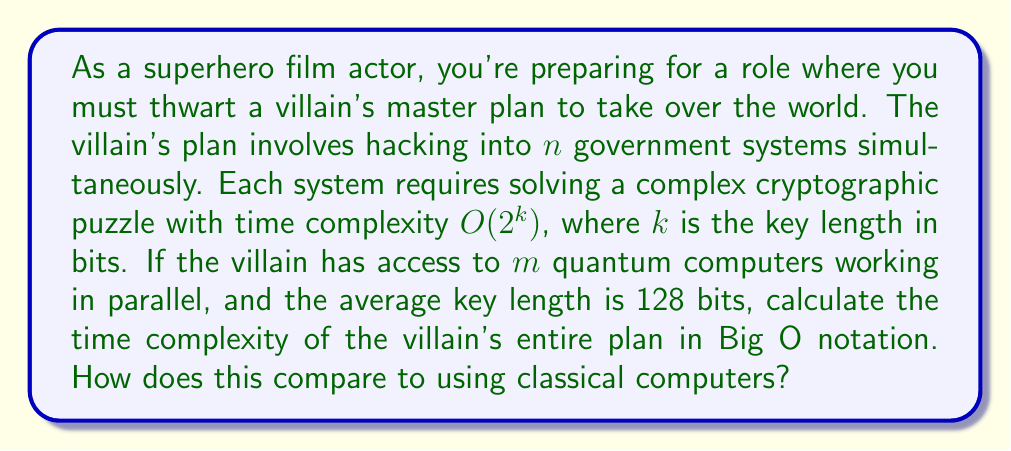Can you solve this math problem? To solve this problem, let's break it down into steps:

1) For a single system with key length $k$, the time complexity is $O(2^k)$.

2) The average key length is 128 bits, so for one system:
   $O(2^{128})$

3) The villain needs to hack $n$ systems. If done sequentially, this would be:
   $O(n \cdot 2^{128})$

4) However, the villain has $m$ quantum computers working in parallel. In the best-case scenario, this could divide the time by $m$:
   $O(\frac{n \cdot 2^{128}}{m})$

5) Quantum computers, however, can use Grover's algorithm for unstructured search problems like this. Grover's algorithm provides a quadratic speedup, effectively reducing the exponent by half:
   $O(\frac{n \cdot 2^{64}}{m})$

6) In Big O notation, we typically don't include constant factors, so $m$ can be omitted:
   $O(n \cdot 2^{64})$

Comparing to classical computers:
- Classical: $O(n \cdot 2^{128})$
- Quantum: $O(n \cdot 2^{64})$

The quantum approach is significantly faster, with a quadratic speedup in the exponent.
Answer: The time complexity of the villain's plan using quantum computers is $O(n \cdot 2^{64})$, which is quadratically faster than the classical approach of $O(n \cdot 2^{128})$. 